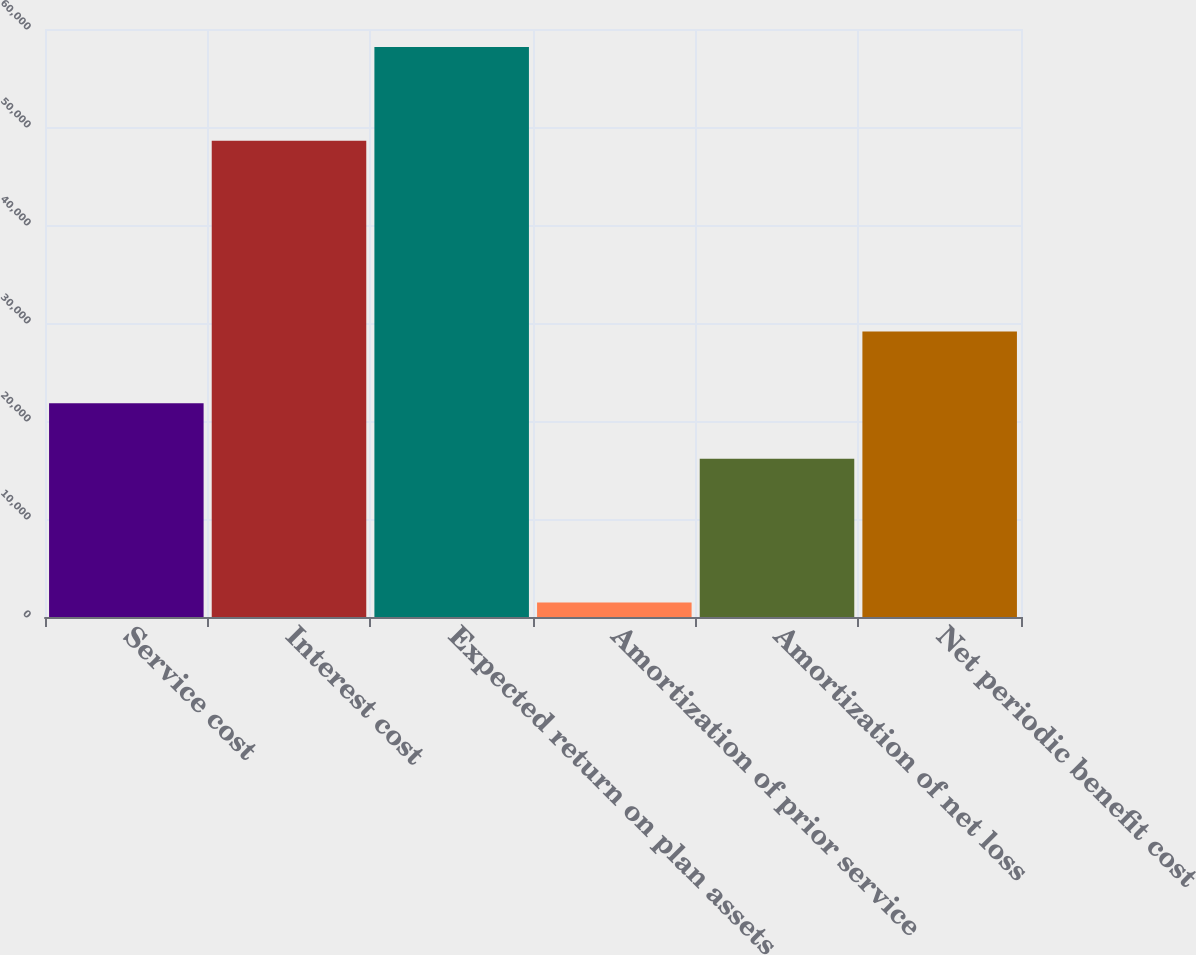Convert chart to OTSL. <chart><loc_0><loc_0><loc_500><loc_500><bar_chart><fcel>Service cost<fcel>Interest cost<fcel>Expected return on plan assets<fcel>Amortization of prior service<fcel>Amortization of net loss<fcel>Net periodic benefit cost<nl><fcel>21805.8<fcel>48608<fcel>58154<fcel>1486<fcel>16139<fcel>29129<nl></chart> 